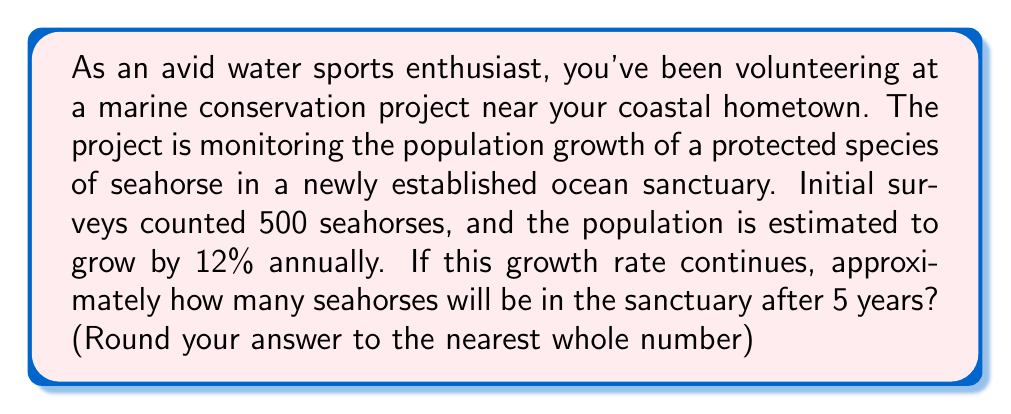Solve this math problem. Let's approach this step-by-step using the compound interest formula, as population growth follows a similar pattern:

1) The formula for compound growth is:
   $$A = P(1 + r)^t$$
   Where:
   $A$ = Final amount
   $P$ = Initial population
   $r$ = Growth rate (as a decimal)
   $t$ = Time period

2) We know:
   $P = 500$ (initial population)
   $r = 0.12$ (12% written as a decimal)
   $t = 5$ years

3) Let's plug these values into our formula:
   $$A = 500(1 + 0.12)^5$$

4) Simplify inside the parentheses:
   $$A = 500(1.12)^5$$

5) Calculate the exponent:
   $$A = 500 * 1.7623416$$

6) Multiply:
   $$A = 881.1708$$

7) Rounding to the nearest whole number:
   $$A ≈ 881$$
Answer: 881 seahorses 